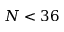<formula> <loc_0><loc_0><loc_500><loc_500>N < 3 6</formula> 